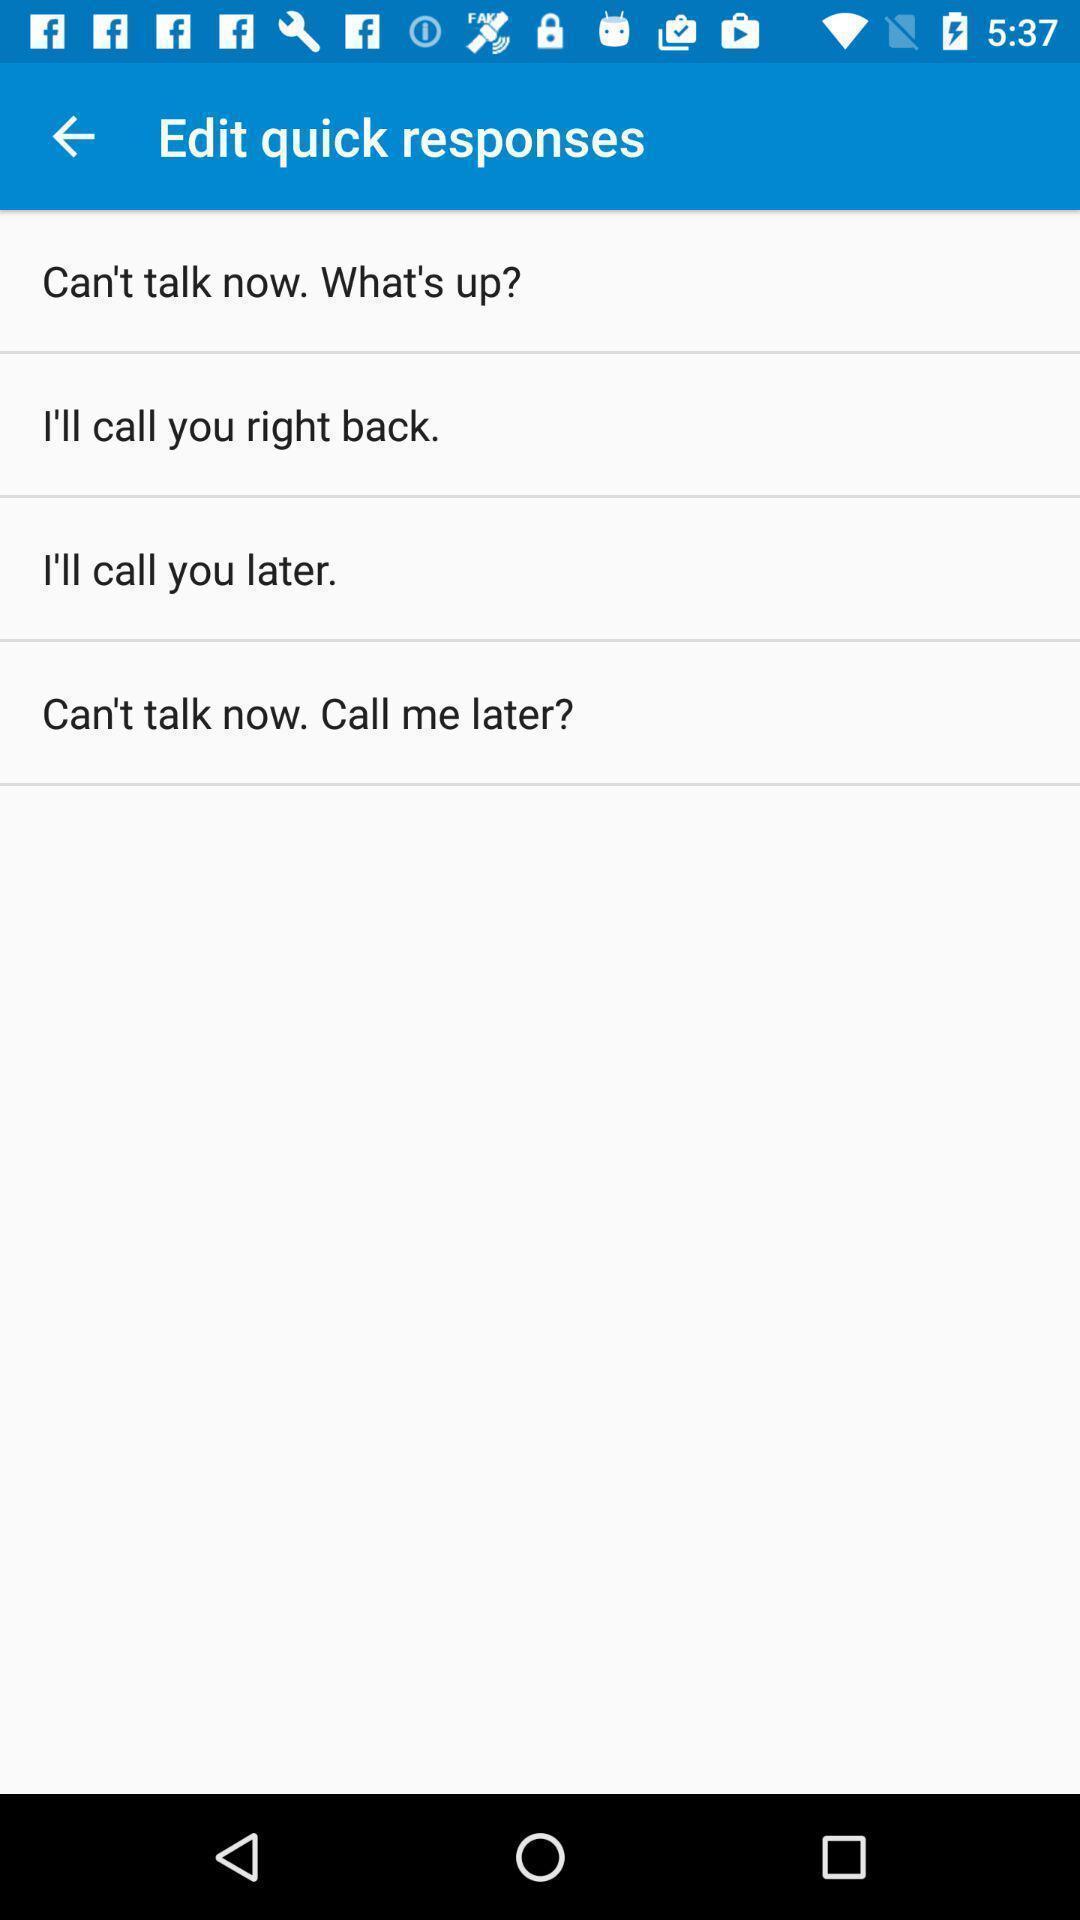Explain the elements present in this screenshot. Page to edit quick responses. 